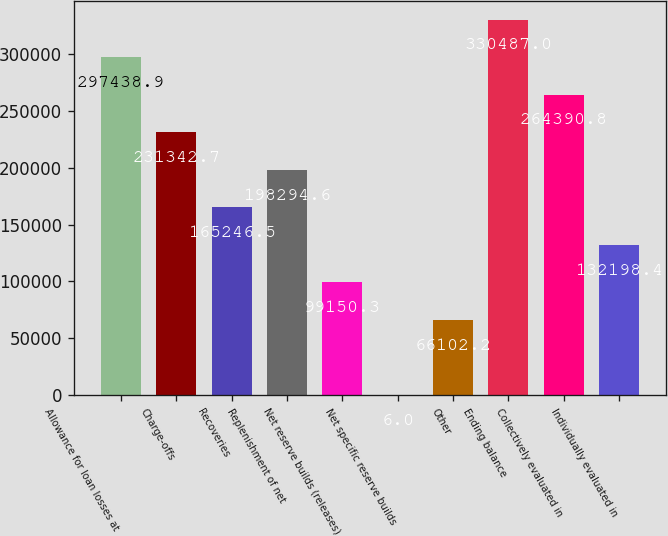Convert chart to OTSL. <chart><loc_0><loc_0><loc_500><loc_500><bar_chart><fcel>Allowance for loan losses at<fcel>Charge-offs<fcel>Recoveries<fcel>Replenishment of net<fcel>Net reserve builds (releases)<fcel>Net specific reserve builds<fcel>Other<fcel>Ending balance<fcel>Collectively evaluated in<fcel>Individually evaluated in<nl><fcel>297439<fcel>231343<fcel>165246<fcel>198295<fcel>99150.3<fcel>6<fcel>66102.2<fcel>330487<fcel>264391<fcel>132198<nl></chart> 